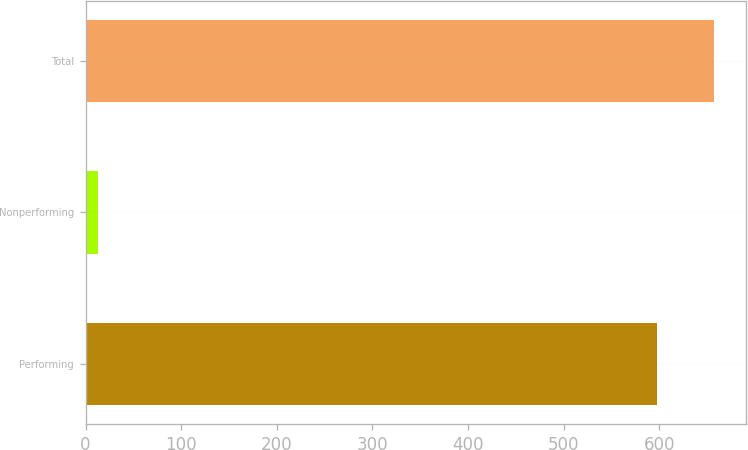Convert chart to OTSL. <chart><loc_0><loc_0><loc_500><loc_500><bar_chart><fcel>Performing<fcel>Nonperforming<fcel>Total<nl><fcel>597.8<fcel>13.2<fcel>657.58<nl></chart> 